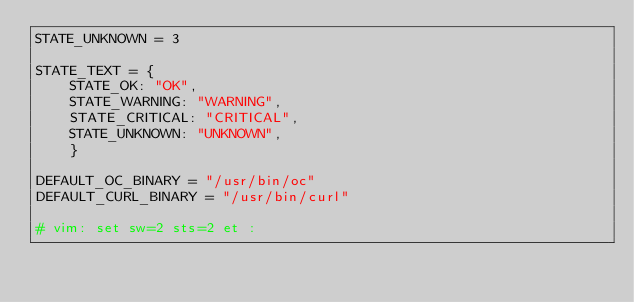Convert code to text. <code><loc_0><loc_0><loc_500><loc_500><_Python_>STATE_UNKNOWN = 3

STATE_TEXT = {
    STATE_OK: "OK",
    STATE_WARNING: "WARNING",
    STATE_CRITICAL: "CRITICAL",
    STATE_UNKNOWN: "UNKNOWN",
    }

DEFAULT_OC_BINARY = "/usr/bin/oc"
DEFAULT_CURL_BINARY = "/usr/bin/curl"

# vim: set sw=2 sts=2 et :
</code> 